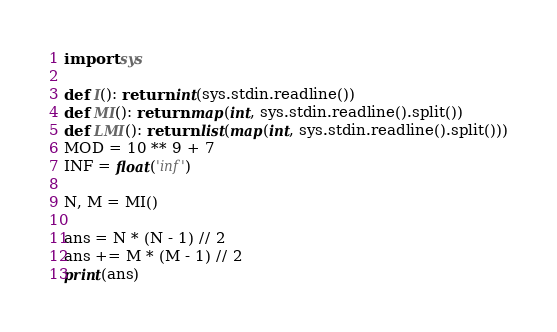<code> <loc_0><loc_0><loc_500><loc_500><_Python_>import sys

def I(): return int(sys.stdin.readline())
def MI(): return map(int, sys.stdin.readline().split())
def LMI(): return list(map(int, sys.stdin.readline().split()))
MOD = 10 ** 9 + 7
INF = float('inf')

N, M = MI()

ans = N * (N - 1) // 2
ans += M * (M - 1) // 2
print(ans)</code> 